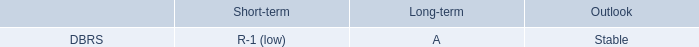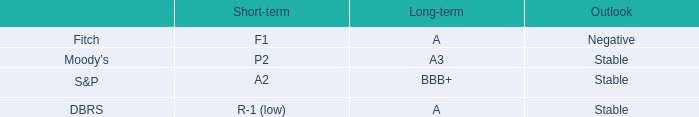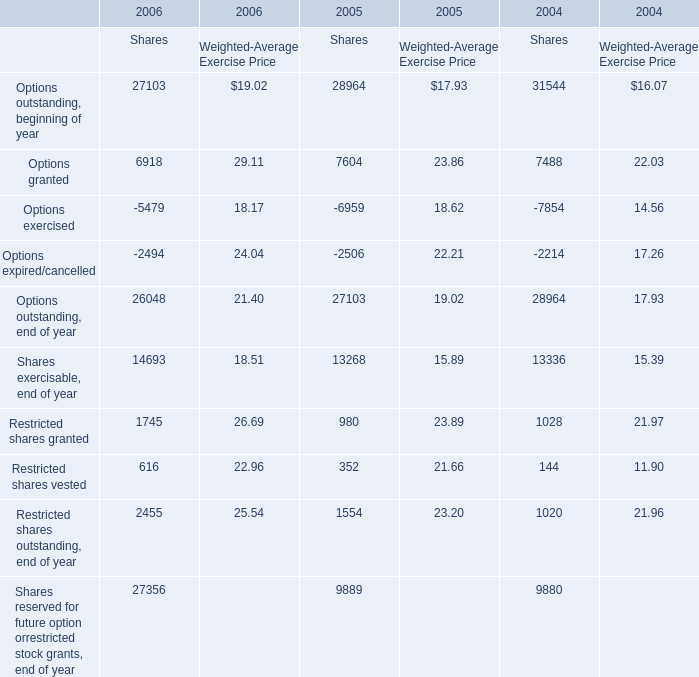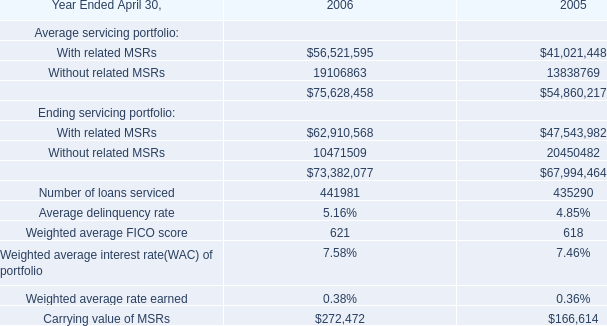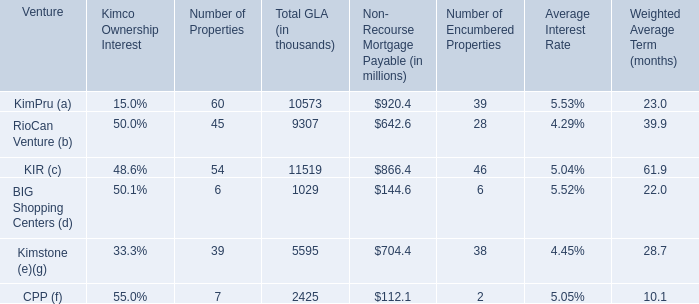What's the average of Options outstanding, end of year of 2006 Shares, and With related MSRs of 2006 ? 
Computations: ((26048.0 + 56521595.0) / 2)
Answer: 28273821.5. 